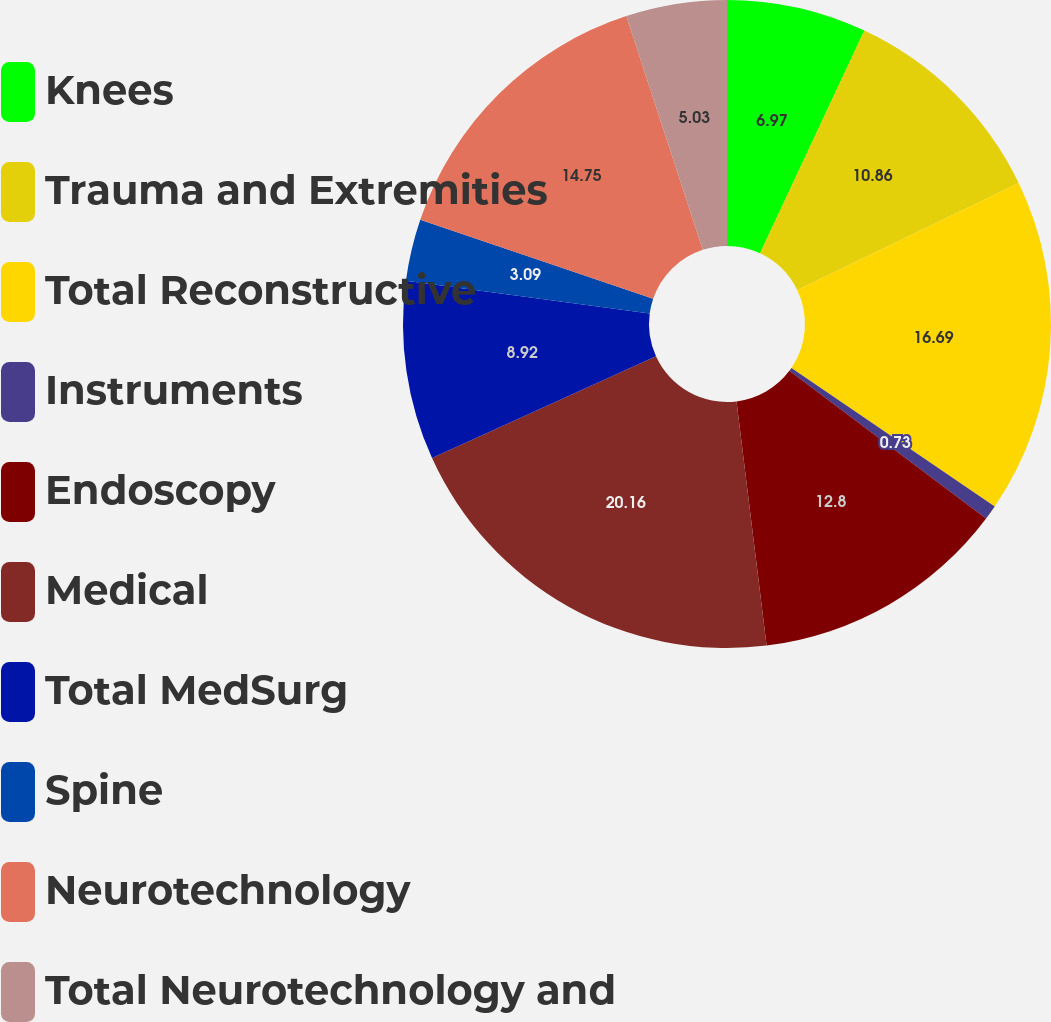Convert chart to OTSL. <chart><loc_0><loc_0><loc_500><loc_500><pie_chart><fcel>Knees<fcel>Trauma and Extremities<fcel>Total Reconstructive<fcel>Instruments<fcel>Endoscopy<fcel>Medical<fcel>Total MedSurg<fcel>Spine<fcel>Neurotechnology<fcel>Total Neurotechnology and<nl><fcel>6.97%<fcel>10.86%<fcel>16.69%<fcel>0.73%<fcel>12.8%<fcel>20.16%<fcel>8.92%<fcel>3.09%<fcel>14.75%<fcel>5.03%<nl></chart> 